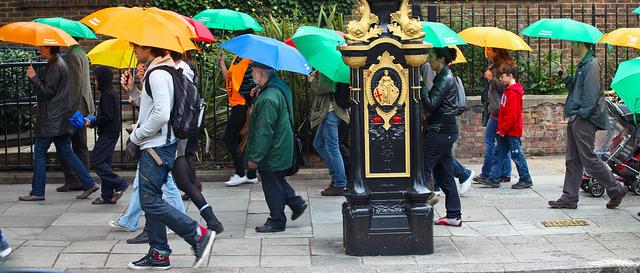What color is the statue near the building?
Keep it brief. Black and gold. Is this an umbrella exhibition?
Keep it brief. No. How many green umbrellas are in the photo?
Write a very short answer. 6. How many red umbrellas are there?
Write a very short answer. 2. How many yellow umbrellas are there?
Keep it brief. 4. Is this an usual position for an umbrella?
Be succinct. Yes. 